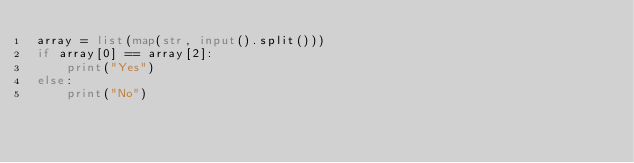<code> <loc_0><loc_0><loc_500><loc_500><_Python_>array = list(map(str, input().split()))
if array[0] == array[2]:
    print("Yes")
else:
    print("No")</code> 